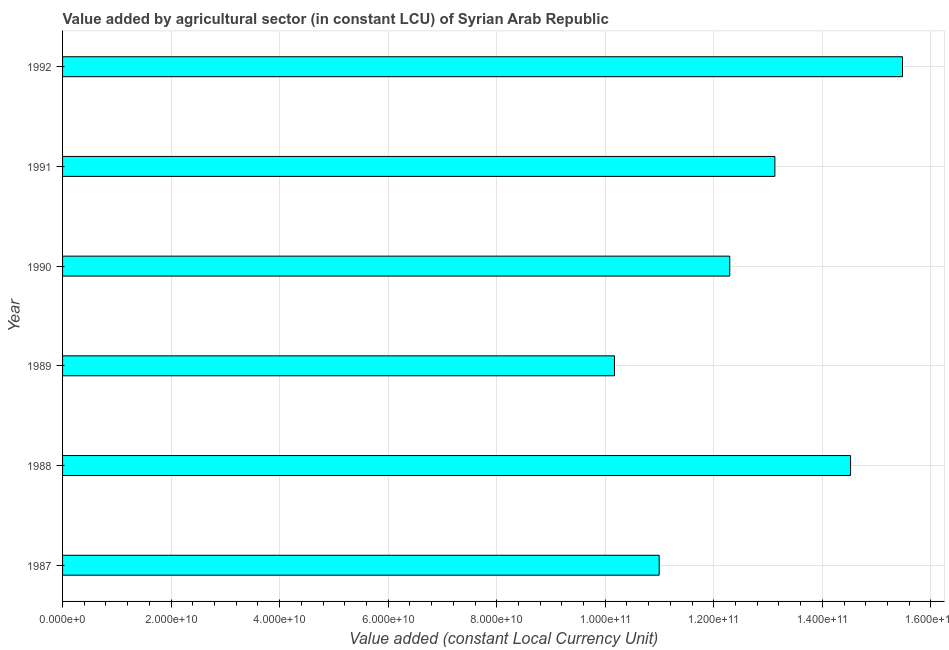Does the graph contain grids?
Offer a very short reply. Yes. What is the title of the graph?
Give a very brief answer. Value added by agricultural sector (in constant LCU) of Syrian Arab Republic. What is the label or title of the X-axis?
Your answer should be very brief. Value added (constant Local Currency Unit). What is the value added by agriculture sector in 1989?
Provide a succinct answer. 1.02e+11. Across all years, what is the maximum value added by agriculture sector?
Provide a short and direct response. 1.55e+11. Across all years, what is the minimum value added by agriculture sector?
Your answer should be very brief. 1.02e+11. In which year was the value added by agriculture sector maximum?
Keep it short and to the point. 1992. In which year was the value added by agriculture sector minimum?
Provide a succinct answer. 1989. What is the sum of the value added by agriculture sector?
Your answer should be very brief. 7.66e+11. What is the difference between the value added by agriculture sector in 1991 and 1992?
Make the answer very short. -2.35e+1. What is the average value added by agriculture sector per year?
Ensure brevity in your answer.  1.28e+11. What is the median value added by agriculture sector?
Your response must be concise. 1.27e+11. Do a majority of the years between 1987 and 1992 (inclusive) have value added by agriculture sector greater than 128000000000 LCU?
Give a very brief answer. No. What is the ratio of the value added by agriculture sector in 1988 to that in 1992?
Offer a terse response. 0.94. Is the value added by agriculture sector in 1989 less than that in 1992?
Provide a succinct answer. Yes. What is the difference between the highest and the second highest value added by agriculture sector?
Provide a short and direct response. 9.57e+09. What is the difference between the highest and the lowest value added by agriculture sector?
Ensure brevity in your answer.  5.31e+1. How many bars are there?
Offer a terse response. 6. How many years are there in the graph?
Ensure brevity in your answer.  6. What is the difference between two consecutive major ticks on the X-axis?
Give a very brief answer. 2.00e+1. Are the values on the major ticks of X-axis written in scientific E-notation?
Your answer should be compact. Yes. What is the Value added (constant Local Currency Unit) in 1987?
Your answer should be compact. 1.10e+11. What is the Value added (constant Local Currency Unit) in 1988?
Keep it short and to the point. 1.45e+11. What is the Value added (constant Local Currency Unit) of 1989?
Offer a very short reply. 1.02e+11. What is the Value added (constant Local Currency Unit) in 1990?
Give a very brief answer. 1.23e+11. What is the Value added (constant Local Currency Unit) of 1991?
Provide a succinct answer. 1.31e+11. What is the Value added (constant Local Currency Unit) of 1992?
Keep it short and to the point. 1.55e+11. What is the difference between the Value added (constant Local Currency Unit) in 1987 and 1988?
Give a very brief answer. -3.53e+1. What is the difference between the Value added (constant Local Currency Unit) in 1987 and 1989?
Offer a very short reply. 8.24e+09. What is the difference between the Value added (constant Local Currency Unit) in 1987 and 1990?
Give a very brief answer. -1.30e+1. What is the difference between the Value added (constant Local Currency Unit) in 1987 and 1991?
Your answer should be very brief. -2.13e+1. What is the difference between the Value added (constant Local Currency Unit) in 1987 and 1992?
Make the answer very short. -4.48e+1. What is the difference between the Value added (constant Local Currency Unit) in 1988 and 1989?
Offer a very short reply. 4.35e+1. What is the difference between the Value added (constant Local Currency Unit) in 1988 and 1990?
Ensure brevity in your answer.  2.23e+1. What is the difference between the Value added (constant Local Currency Unit) in 1988 and 1991?
Provide a succinct answer. 1.39e+1. What is the difference between the Value added (constant Local Currency Unit) in 1988 and 1992?
Keep it short and to the point. -9.57e+09. What is the difference between the Value added (constant Local Currency Unit) in 1989 and 1990?
Ensure brevity in your answer.  -2.12e+1. What is the difference between the Value added (constant Local Currency Unit) in 1989 and 1991?
Your answer should be very brief. -2.96e+1. What is the difference between the Value added (constant Local Currency Unit) in 1989 and 1992?
Your response must be concise. -5.31e+1. What is the difference between the Value added (constant Local Currency Unit) in 1990 and 1991?
Ensure brevity in your answer.  -8.32e+09. What is the difference between the Value added (constant Local Currency Unit) in 1990 and 1992?
Your answer should be very brief. -3.18e+1. What is the difference between the Value added (constant Local Currency Unit) in 1991 and 1992?
Your answer should be very brief. -2.35e+1. What is the ratio of the Value added (constant Local Currency Unit) in 1987 to that in 1988?
Your answer should be very brief. 0.76. What is the ratio of the Value added (constant Local Currency Unit) in 1987 to that in 1989?
Your answer should be compact. 1.08. What is the ratio of the Value added (constant Local Currency Unit) in 1987 to that in 1990?
Offer a terse response. 0.89. What is the ratio of the Value added (constant Local Currency Unit) in 1987 to that in 1991?
Your response must be concise. 0.84. What is the ratio of the Value added (constant Local Currency Unit) in 1987 to that in 1992?
Your response must be concise. 0.71. What is the ratio of the Value added (constant Local Currency Unit) in 1988 to that in 1989?
Offer a terse response. 1.43. What is the ratio of the Value added (constant Local Currency Unit) in 1988 to that in 1990?
Your answer should be very brief. 1.18. What is the ratio of the Value added (constant Local Currency Unit) in 1988 to that in 1991?
Provide a succinct answer. 1.11. What is the ratio of the Value added (constant Local Currency Unit) in 1988 to that in 1992?
Provide a succinct answer. 0.94. What is the ratio of the Value added (constant Local Currency Unit) in 1989 to that in 1990?
Keep it short and to the point. 0.83. What is the ratio of the Value added (constant Local Currency Unit) in 1989 to that in 1991?
Offer a terse response. 0.78. What is the ratio of the Value added (constant Local Currency Unit) in 1989 to that in 1992?
Provide a short and direct response. 0.66. What is the ratio of the Value added (constant Local Currency Unit) in 1990 to that in 1991?
Ensure brevity in your answer.  0.94. What is the ratio of the Value added (constant Local Currency Unit) in 1990 to that in 1992?
Offer a very short reply. 0.79. What is the ratio of the Value added (constant Local Currency Unit) in 1991 to that in 1992?
Provide a succinct answer. 0.85. 